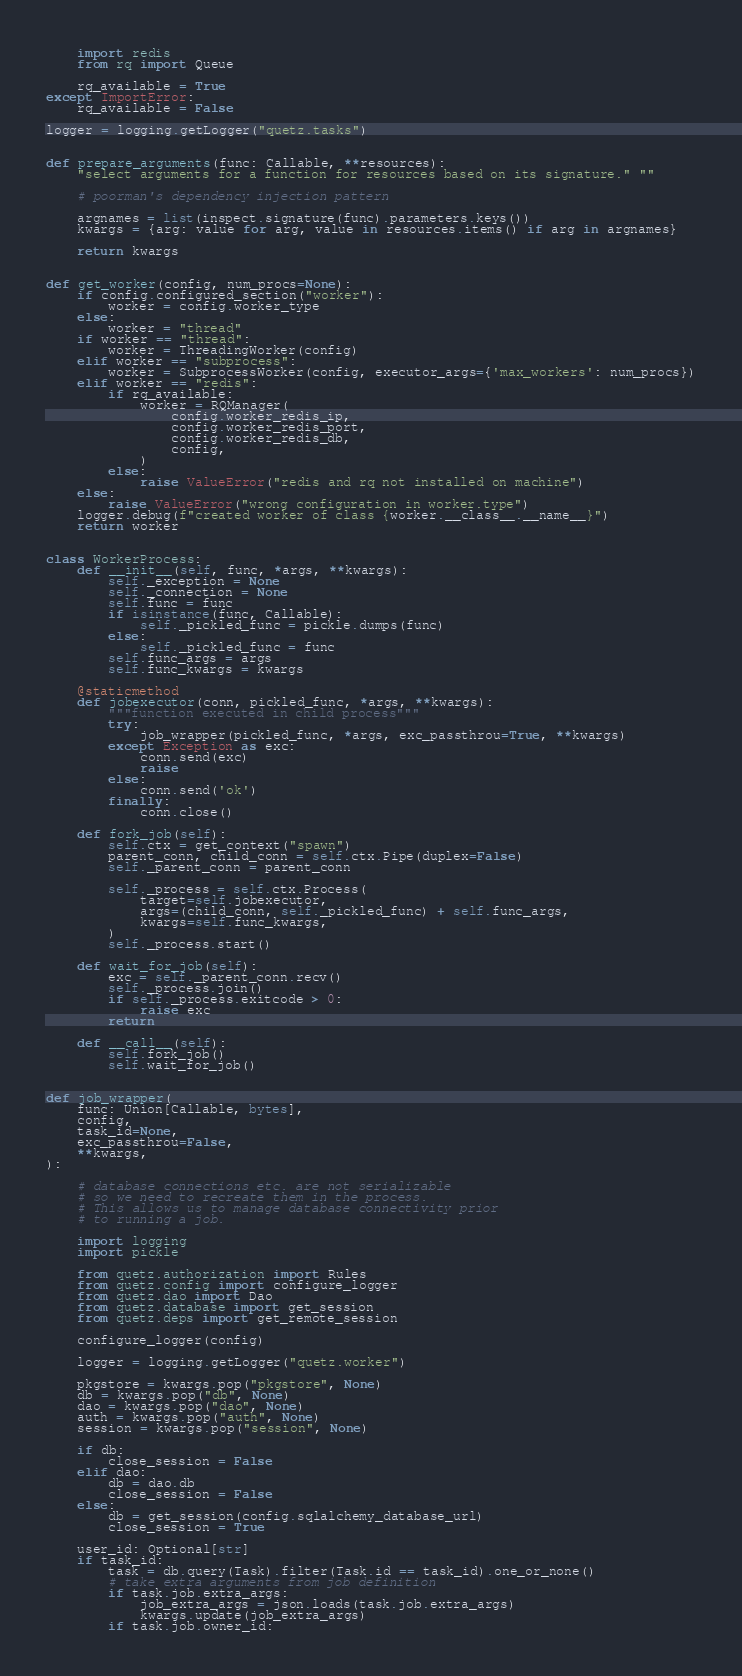Convert code to text. <code><loc_0><loc_0><loc_500><loc_500><_Python_>    import redis
    from rq import Queue

    rq_available = True
except ImportError:
    rq_available = False

logger = logging.getLogger("quetz.tasks")


def prepare_arguments(func: Callable, **resources):
    "select arguments for a function for resources based on its signature." ""

    # poorman's dependency injection pattern

    argnames = list(inspect.signature(func).parameters.keys())
    kwargs = {arg: value for arg, value in resources.items() if arg in argnames}

    return kwargs


def get_worker(config, num_procs=None):
    if config.configured_section("worker"):
        worker = config.worker_type
    else:
        worker = "thread"
    if worker == "thread":
        worker = ThreadingWorker(config)
    elif worker == "subprocess":
        worker = SubprocessWorker(config, executor_args={'max_workers': num_procs})
    elif worker == "redis":
        if rq_available:
            worker = RQManager(
                config.worker_redis_ip,
                config.worker_redis_port,
                config.worker_redis_db,
                config,
            )
        else:
            raise ValueError("redis and rq not installed on machine")
    else:
        raise ValueError("wrong configuration in worker.type")
    logger.debug(f"created worker of class {worker.__class__.__name__}")
    return worker


class WorkerProcess:
    def __init__(self, func, *args, **kwargs):
        self._exception = None
        self._connection = None
        self.func = func
        if isinstance(func, Callable):
            self._pickled_func = pickle.dumps(func)
        else:
            self._pickled_func = func
        self.func_args = args
        self.func_kwargs = kwargs

    @staticmethod
    def jobexecutor(conn, pickled_func, *args, **kwargs):
        """function executed in child process"""
        try:
            job_wrapper(pickled_func, *args, exc_passthrou=True, **kwargs)
        except Exception as exc:
            conn.send(exc)
            raise
        else:
            conn.send('ok')
        finally:
            conn.close()

    def fork_job(self):
        self.ctx = get_context("spawn")
        parent_conn, child_conn = self.ctx.Pipe(duplex=False)
        self._parent_conn = parent_conn

        self._process = self.ctx.Process(
            target=self.jobexecutor,
            args=(child_conn, self._pickled_func) + self.func_args,
            kwargs=self.func_kwargs,
        )
        self._process.start()

    def wait_for_job(self):
        exc = self._parent_conn.recv()
        self._process.join()
        if self._process.exitcode > 0:
            raise exc
        return

    def __call__(self):
        self.fork_job()
        self.wait_for_job()


def job_wrapper(
    func: Union[Callable, bytes],
    config,
    task_id=None,
    exc_passthrou=False,
    **kwargs,
):

    # database connections etc. are not serializable
    # so we need to recreate them in the process.
    # This allows us to manage database connectivity prior
    # to running a job.

    import logging
    import pickle

    from quetz.authorization import Rules
    from quetz.config import configure_logger
    from quetz.dao import Dao
    from quetz.database import get_session
    from quetz.deps import get_remote_session

    configure_logger(config)

    logger = logging.getLogger("quetz.worker")

    pkgstore = kwargs.pop("pkgstore", None)
    db = kwargs.pop("db", None)
    dao = kwargs.pop("dao", None)
    auth = kwargs.pop("auth", None)
    session = kwargs.pop("session", None)

    if db:
        close_session = False
    elif dao:
        db = dao.db
        close_session = False
    else:
        db = get_session(config.sqlalchemy_database_url)
        close_session = True

    user_id: Optional[str]
    if task_id:
        task = db.query(Task).filter(Task.id == task_id).one_or_none()
        # take extra arguments from job definition
        if task.job.extra_args:
            job_extra_args = json.loads(task.job.extra_args)
            kwargs.update(job_extra_args)
        if task.job.owner_id:</code> 